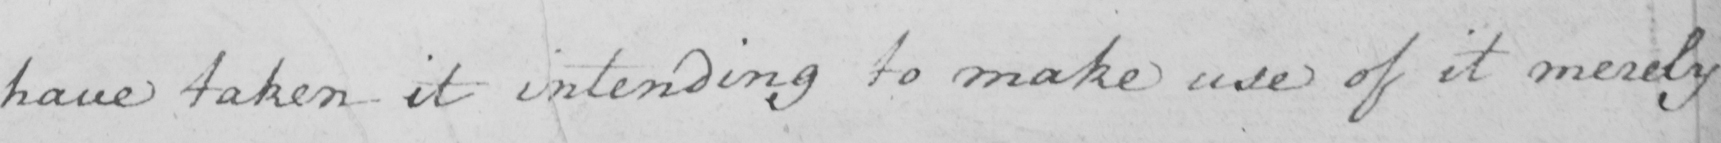Please transcribe the handwritten text in this image. have taken it intending to make use of it merely 